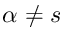Convert formula to latex. <formula><loc_0><loc_0><loc_500><loc_500>\alpha \neq s</formula> 